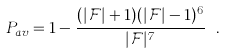Convert formula to latex. <formula><loc_0><loc_0><loc_500><loc_500>P _ { a v } = 1 - \frac { ( | \mathcal { F } | + 1 ) ( | \mathcal { F } | - 1 ) ^ { 6 } } { | \mathcal { F } | ^ { 7 } } \ .</formula> 